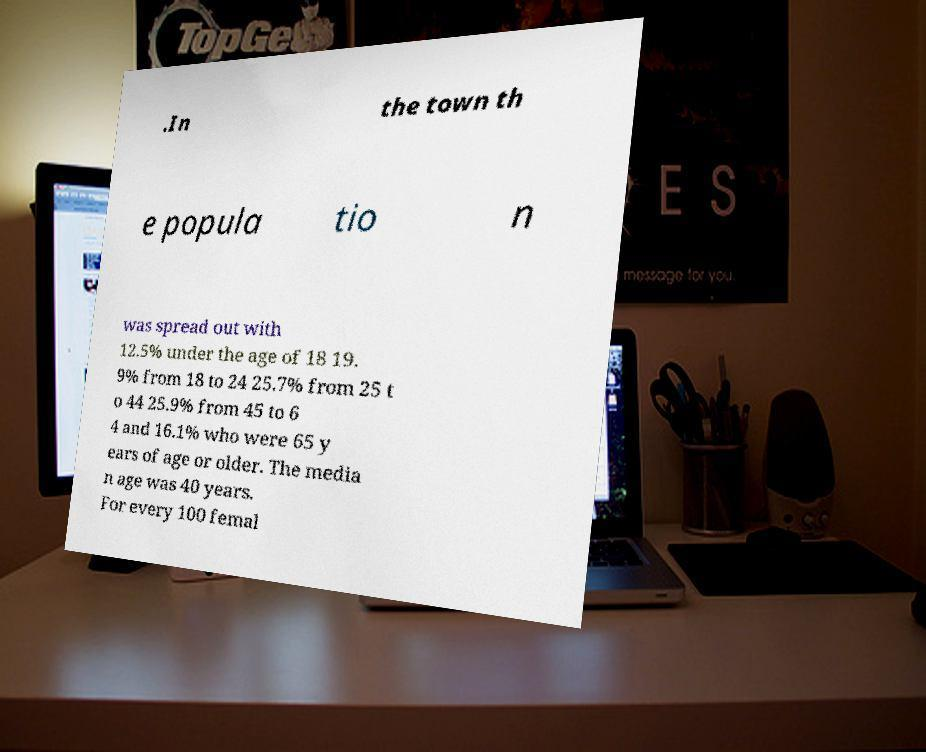Please identify and transcribe the text found in this image. .In the town th e popula tio n was spread out with 12.5% under the age of 18 19. 9% from 18 to 24 25.7% from 25 t o 44 25.9% from 45 to 6 4 and 16.1% who were 65 y ears of age or older. The media n age was 40 years. For every 100 femal 